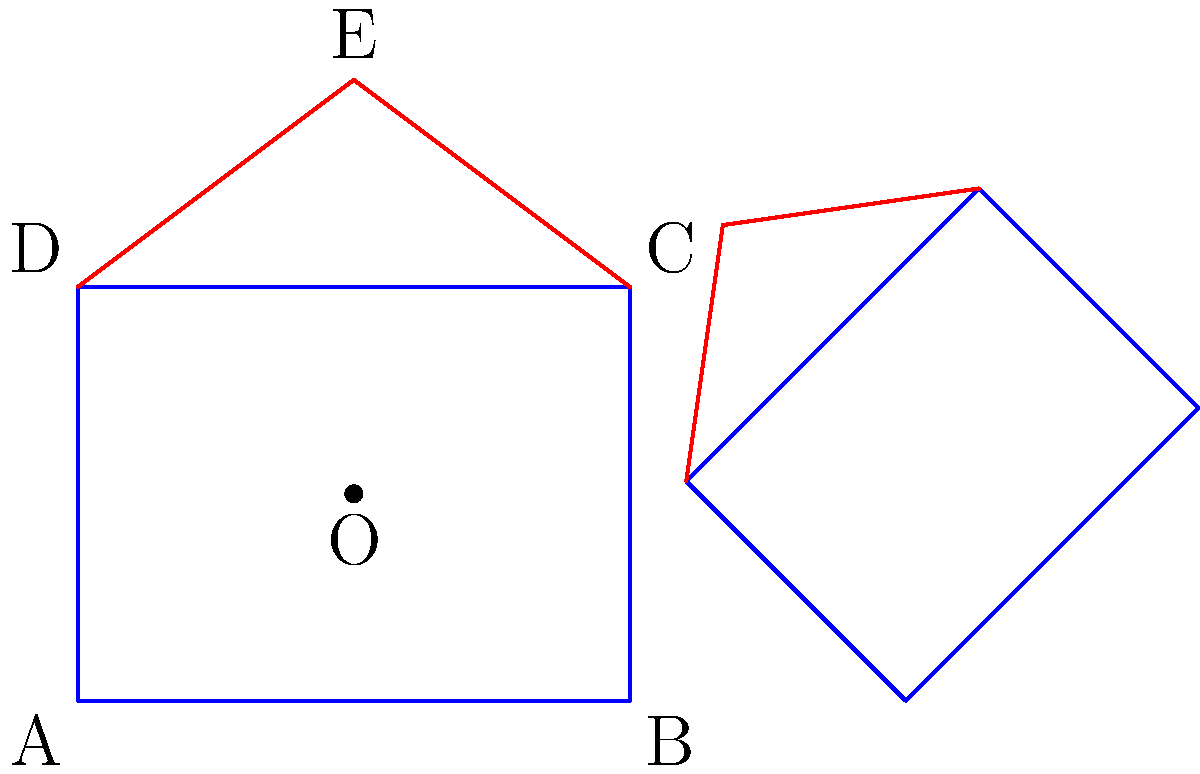A government building is represented by the pentagon ABCDE, where ABCD forms the main structure and CDE forms the roof. The building undergoes a series of transformations: first, it is rotated 45° clockwise around point O (2, 1.5), then scaled by a factor of 0.75, and finally translated 6 units to the right. What is the area of the transformed building as a fraction of the original building's area? Let's approach this step-by-step:

1) The original building consists of a rectangle ABCD and a triangular roof CDE.

2) The transformations applied are:
   a) Rotation by 45° clockwise around O(2, 1.5)
   b) Scaling by a factor of 0.75
   c) Translation 6 units to the right

3) Rotation and translation do not affect the area of a shape, so we only need to consider the scaling transformation.

4) When a shape is scaled by a factor of $k$, its area is scaled by a factor of $k^2$.

5) In this case, the scaling factor is 0.75, so the area will be scaled by $(0.75)^2 = 0.5625$.

6) This means the area of the transformed building will be 0.5625 times the area of the original building.

7) To express this as a fraction:
   $0.5625 = \frac{9}{16}$

Therefore, the area of the transformed building is $\frac{9}{16}$ of the original building's area.
Answer: $\frac{9}{16}$ 